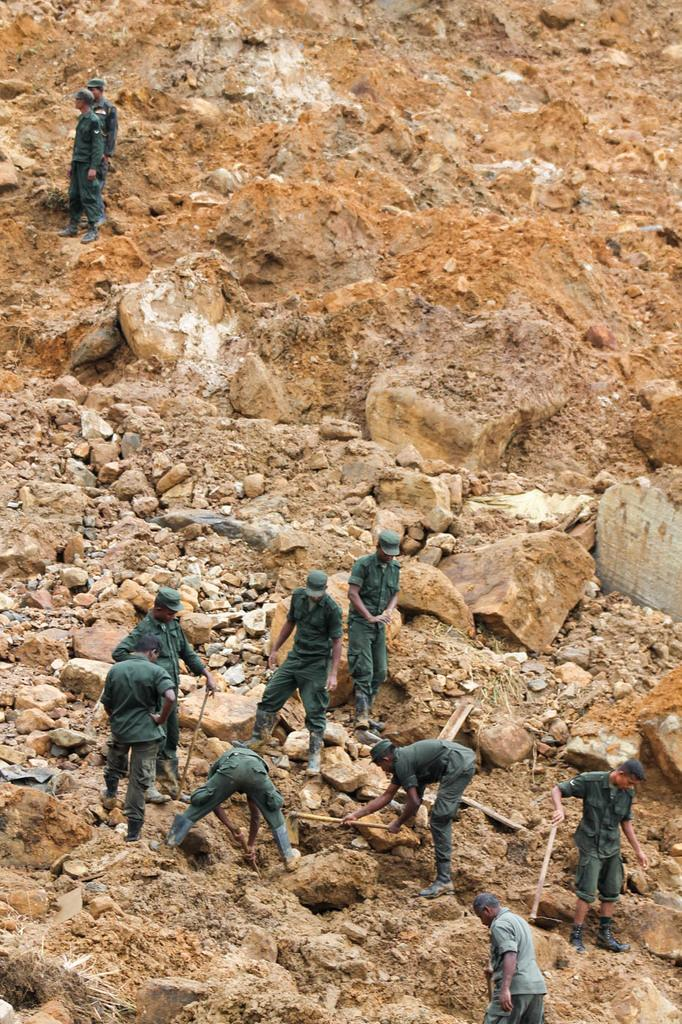Who is present in the image? There are men in the image. What are the men doing in the image? The men are working on a rocky area. What are the men wearing in the image? The men are wearing green color uniforms. How much rice is being cooked by the men in the image? There is no rice or cooking activity present in the image; the men are working on a rocky area. 